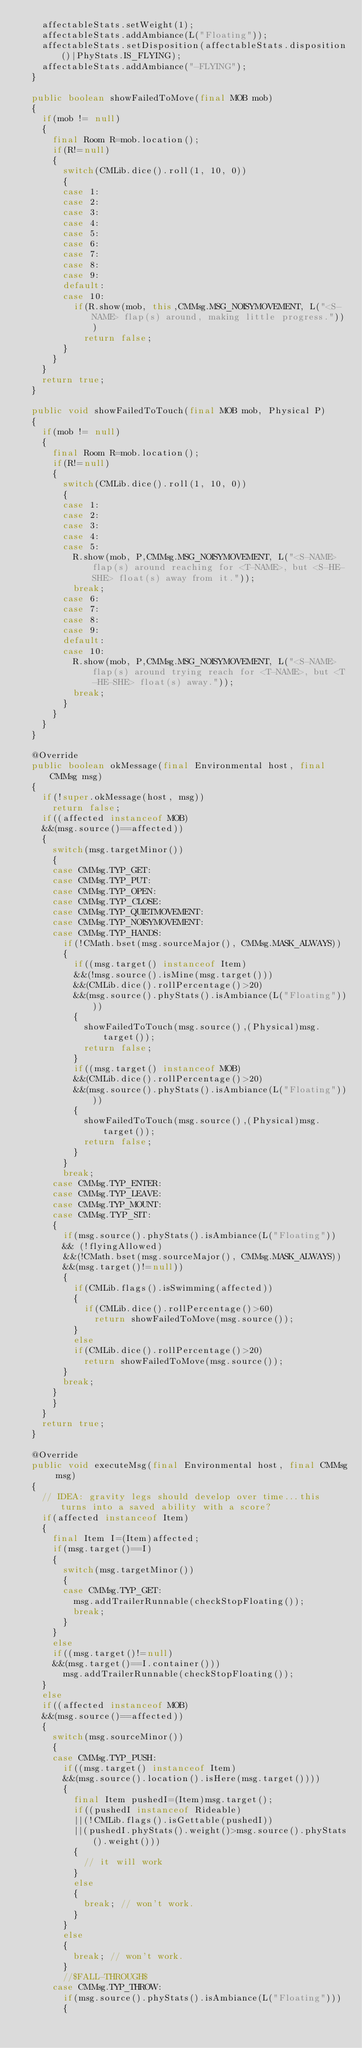<code> <loc_0><loc_0><loc_500><loc_500><_Java_>		affectableStats.setWeight(1);
		affectableStats.addAmbiance(L("Floating"));
		affectableStats.setDisposition(affectableStats.disposition()|PhyStats.IS_FLYING);
		affectableStats.addAmbiance("-FLYING");
	}
	
	public boolean showFailedToMove(final MOB mob)
	{
		if(mob != null)
		{
			final Room R=mob.location();
			if(R!=null)
			{
				switch(CMLib.dice().roll(1, 10, 0))
				{
				case 1:
				case 2:
				case 3:
				case 4:
				case 5:
				case 6:
				case 7:
				case 8:
				case 9:
				default:
				case 10:
					if(R.show(mob, this,CMMsg.MSG_NOISYMOVEMENT, L("<S-NAME> flap(s) around, making little progress.")))
						return false;
				}
			}
		}
		return true;
	}
	
	public void showFailedToTouch(final MOB mob, Physical P)
	{
		if(mob != null)
		{
			final Room R=mob.location();
			if(R!=null)
			{
				switch(CMLib.dice().roll(1, 10, 0))
				{
				case 1:
				case 2:
				case 3:
				case 4:
				case 5:
					R.show(mob, P,CMMsg.MSG_NOISYMOVEMENT, L("<S-NAME> flap(s) around reaching for <T-NAME>, but <S-HE-SHE> float(s) away from it."));
					break;
				case 6:
				case 7:
				case 8:
				case 9:
				default:
				case 10:
					R.show(mob, P,CMMsg.MSG_NOISYMOVEMENT, L("<S-NAME> flap(s) around trying reach for <T-NAME>, but <T-HE-SHE> float(s) away."));
					break;
				}
			}
		}
	}
	
	@Override
	public boolean okMessage(final Environmental host, final CMMsg msg)
	{
		if(!super.okMessage(host, msg))
			return false;
		if((affected instanceof MOB)
		&&(msg.source()==affected))
		{
			switch(msg.targetMinor())
			{
			case CMMsg.TYP_GET:
			case CMMsg.TYP_PUT:
			case CMMsg.TYP_OPEN:
			case CMMsg.TYP_CLOSE:
			case CMMsg.TYP_QUIETMOVEMENT:
			case CMMsg.TYP_NOISYMOVEMENT:
			case CMMsg.TYP_HANDS:
				if(!CMath.bset(msg.sourceMajor(), CMMsg.MASK_ALWAYS))
				{
					if((msg.target() instanceof Item)
					&&(!msg.source().isMine(msg.target()))
					&&(CMLib.dice().rollPercentage()>20)
					&&(msg.source().phyStats().isAmbiance(L("Floating"))))
					{
						showFailedToTouch(msg.source(),(Physical)msg.target());
						return false;
					}
					if((msg.target() instanceof MOB)
					&&(CMLib.dice().rollPercentage()>20)
					&&(msg.source().phyStats().isAmbiance(L("Floating"))))
					{
						showFailedToTouch(msg.source(),(Physical)msg.target());
						return false;
					}
				}
				break;
			case CMMsg.TYP_ENTER:
			case CMMsg.TYP_LEAVE:
			case CMMsg.TYP_MOUNT:
			case CMMsg.TYP_SIT:
			{
				if(msg.source().phyStats().isAmbiance(L("Floating")) 
				&& (!flyingAllowed)
				&&(!CMath.bset(msg.sourceMajor(), CMMsg.MASK_ALWAYS))
				&&(msg.target()!=null))
				{
					if(CMLib.flags().isSwimming(affected))
					{
						if(CMLib.dice().rollPercentage()>60)
							return showFailedToMove(msg.source());
					}
					else
					if(CMLib.dice().rollPercentage()>20)
						return showFailedToMove(msg.source());
				}
				break;
			}
			}
		}
		return true;
	}
	
	@Override
	public void executeMsg(final Environmental host, final CMMsg msg)
	{
		// IDEA: gravity legs should develop over time...this turns into a saved ability with a score?
		if(affected instanceof Item)
		{
			final Item I=(Item)affected;
			if(msg.target()==I)
			{
				switch(msg.targetMinor())
				{
				case CMMsg.TYP_GET:
					msg.addTrailerRunnable(checkStopFloating());
					break;
				}
			}
			else
			if((msg.target()!=null)
			&&(msg.target()==I.container()))
				msg.addTrailerRunnable(checkStopFloating());
		}
		else
		if((affected instanceof MOB)
		&&(msg.source()==affected))
		{
			switch(msg.sourceMinor())
			{
			case CMMsg.TYP_PUSH:
				if((msg.target() instanceof Item)
				&&(msg.source().location().isHere(msg.target())))
				{
					final Item pushedI=(Item)msg.target();
					if((pushedI instanceof Rideable)
					||(!CMLib.flags().isGettable(pushedI))
					||(pushedI.phyStats().weight()>msg.source().phyStats().weight()))
					{
						// it will work
					}
					else
					{
						break; // won't work.
					}
				}
				else
				{
					break; // won't work.
				}
				//$FALL-THROUGH$
			case CMMsg.TYP_THROW:
				if(msg.source().phyStats().isAmbiance(L("Floating")))
				{</code> 